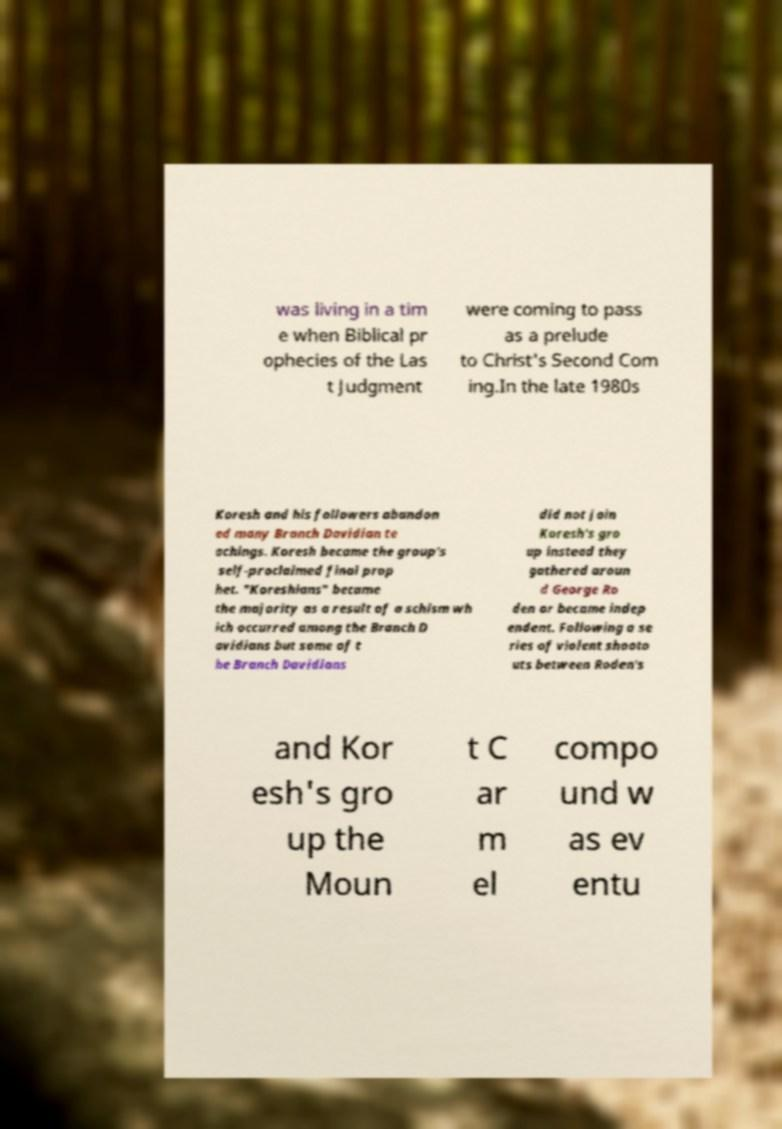Can you read and provide the text displayed in the image?This photo seems to have some interesting text. Can you extract and type it out for me? was living in a tim e when Biblical pr ophecies of the Las t Judgment were coming to pass as a prelude to Christ's Second Com ing.In the late 1980s Koresh and his followers abandon ed many Branch Davidian te achings. Koresh became the group's self-proclaimed final prop het. "Koreshians" became the majority as a result of a schism wh ich occurred among the Branch D avidians but some of t he Branch Davidians did not join Koresh's gro up instead they gathered aroun d George Ro den or became indep endent. Following a se ries of violent shooto uts between Roden's and Kor esh's gro up the Moun t C ar m el compo und w as ev entu 